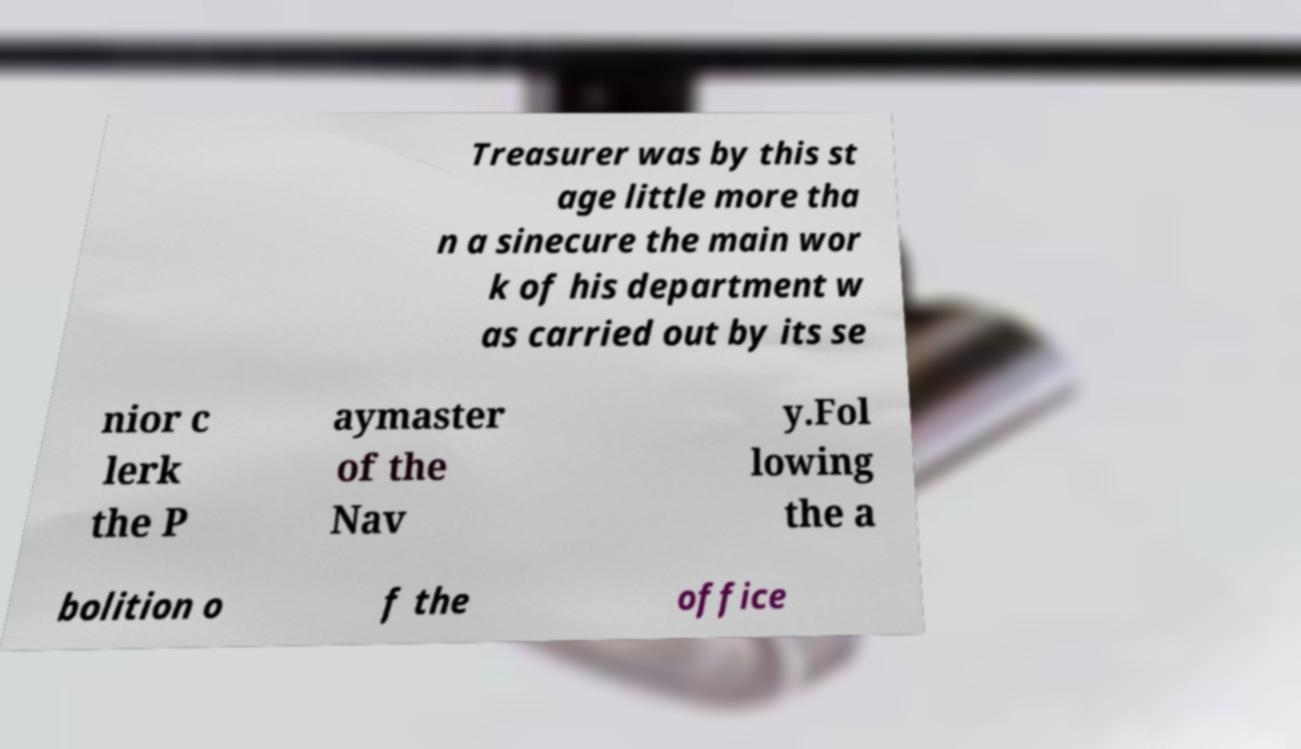I need the written content from this picture converted into text. Can you do that? Treasurer was by this st age little more tha n a sinecure the main wor k of his department w as carried out by its se nior c lerk the P aymaster of the Nav y.Fol lowing the a bolition o f the office 